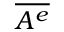Convert formula to latex. <formula><loc_0><loc_0><loc_500><loc_500>\overline { { A ^ { e } } }</formula> 